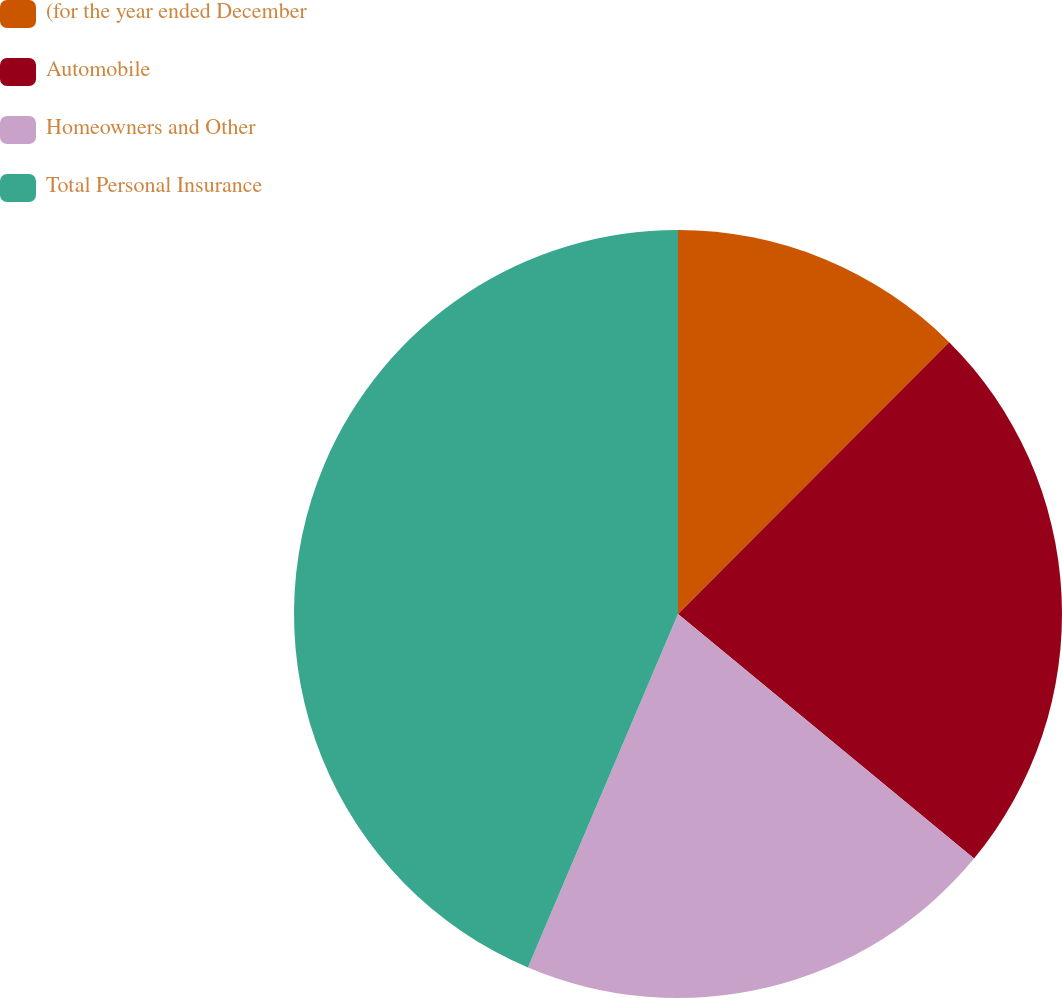<chart> <loc_0><loc_0><loc_500><loc_500><pie_chart><fcel>(for the year ended December<fcel>Automobile<fcel>Homeowners and Other<fcel>Total Personal Insurance<nl><fcel>12.48%<fcel>23.51%<fcel>20.4%<fcel>43.61%<nl></chart> 